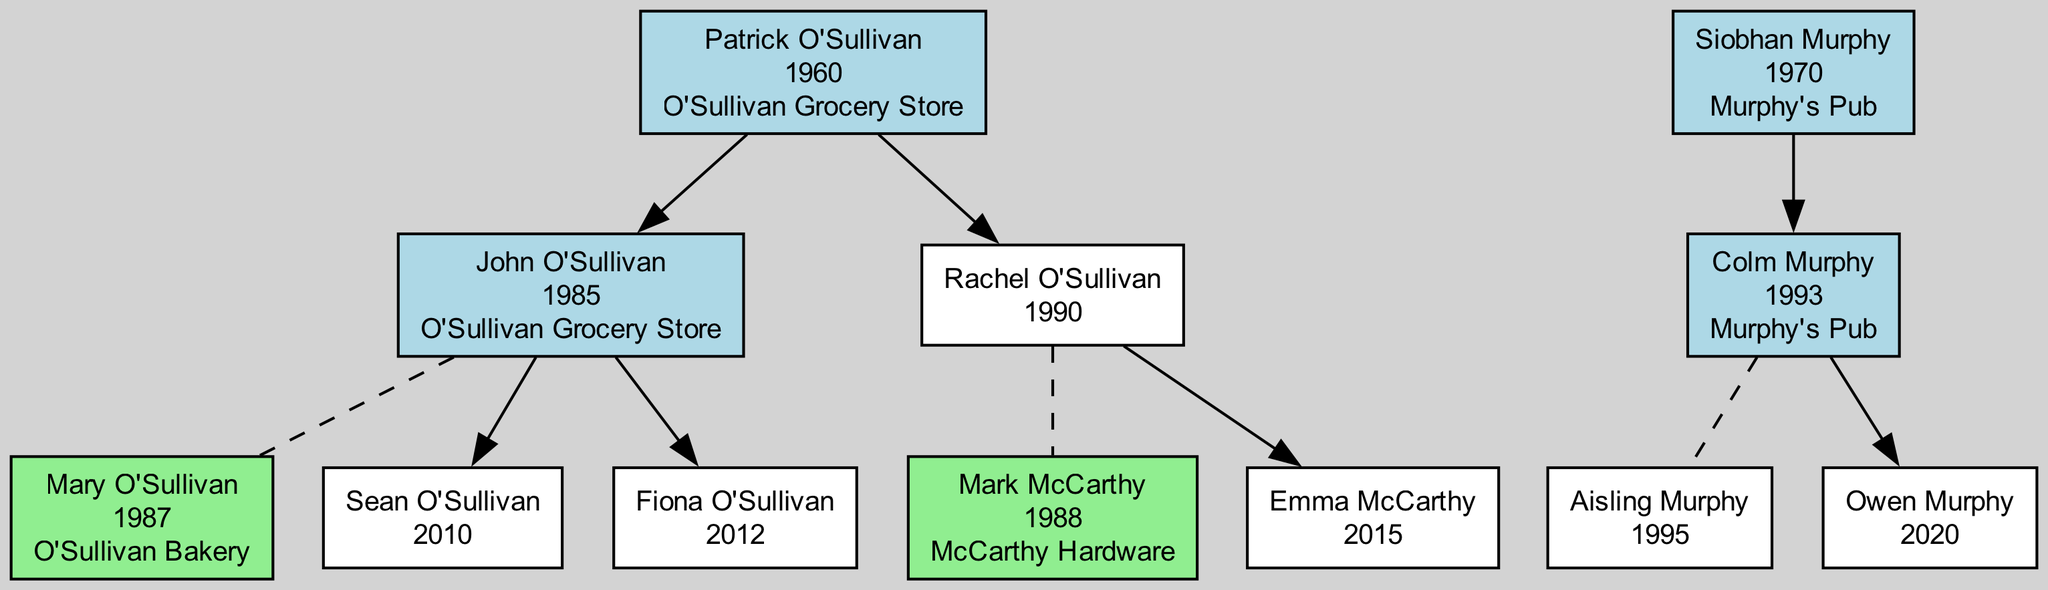What is the name of the owner of O'Sullivan Grocery Store? The diagram indicates that Patrick O'Sullivan is the owner of O'Sullivan Grocery Store. He is directly connected to the business node in the visual representation.
Answer: Patrick O'Sullivan How many children does Siobhan Murphy have? From the diagram, Siobhan Murphy has one child, Colm Murphy, shown as a direct descendant in the family tree.
Answer: 1 What business does Rachel O'Sullivan's spouse own? The diagram shows that Rachel O'Sullivan is married to Mark McCarthy, who owns McCarthy Hardware, as indicated next to his name in the diagram.
Answer: McCarthy Hardware Who are the children of John O'Sullivan? The diagram lists Sean O'Sullivan and Fiona O'Sullivan as the children of John O'Sullivan, which can be determined by looking at the child nodes connected to John in the diagram.
Answer: Sean O'Sullivan, Fiona O'Sullivan Which business is associated with the youngest child of Colm Murphy? The youngest child of Colm Murphy is Owen Murphy, who is born in 2020. The diagram does not assign him a business yet, as his node doesn't indicate any associated business.
Answer: None What is the birth year of Mary O'Sullivan? Mary O'Sullivan's birth year is listed in the diagram next to her name, which is 1987. This information can be found easily in her node.
Answer: 1987 Who owns the business associated with the youngest O'Sullivan child? The youngest O'Sullivan child, Fiona O'Sullivan, does not currently own a business, as evidenced by the absence of a business name in her node.
Answer: None How is Colm Murphy related to Siobhan Murphy? Colm Murphy is the child of Siobhan Murphy, as depicted by the direct connection from Siobhan's node to Colm's node in the diagram.
Answer: Child Which couple in the diagram has a child named Emma? The diagram shows that Rachel O'Sullivan and her spouse, Mark McCarthy, are the parents of Emma McCarthy, making this couple the answer to the question.
Answer: Rachel O'Sullivan and Mark McCarthy 